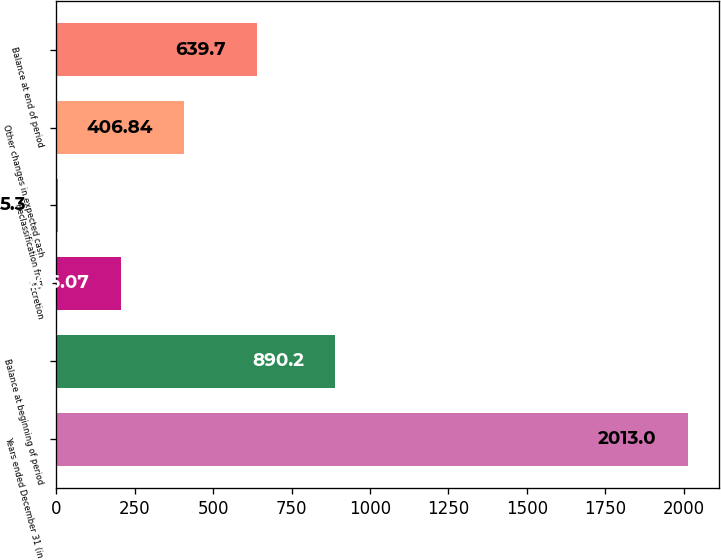<chart> <loc_0><loc_0><loc_500><loc_500><bar_chart><fcel>Years ended December 31 (in<fcel>Balance at beginning of period<fcel>Accretion<fcel>Reclassification from<fcel>Other changes in expected cash<fcel>Balance at end of period<nl><fcel>2013<fcel>890.2<fcel>206.07<fcel>5.3<fcel>406.84<fcel>639.7<nl></chart> 